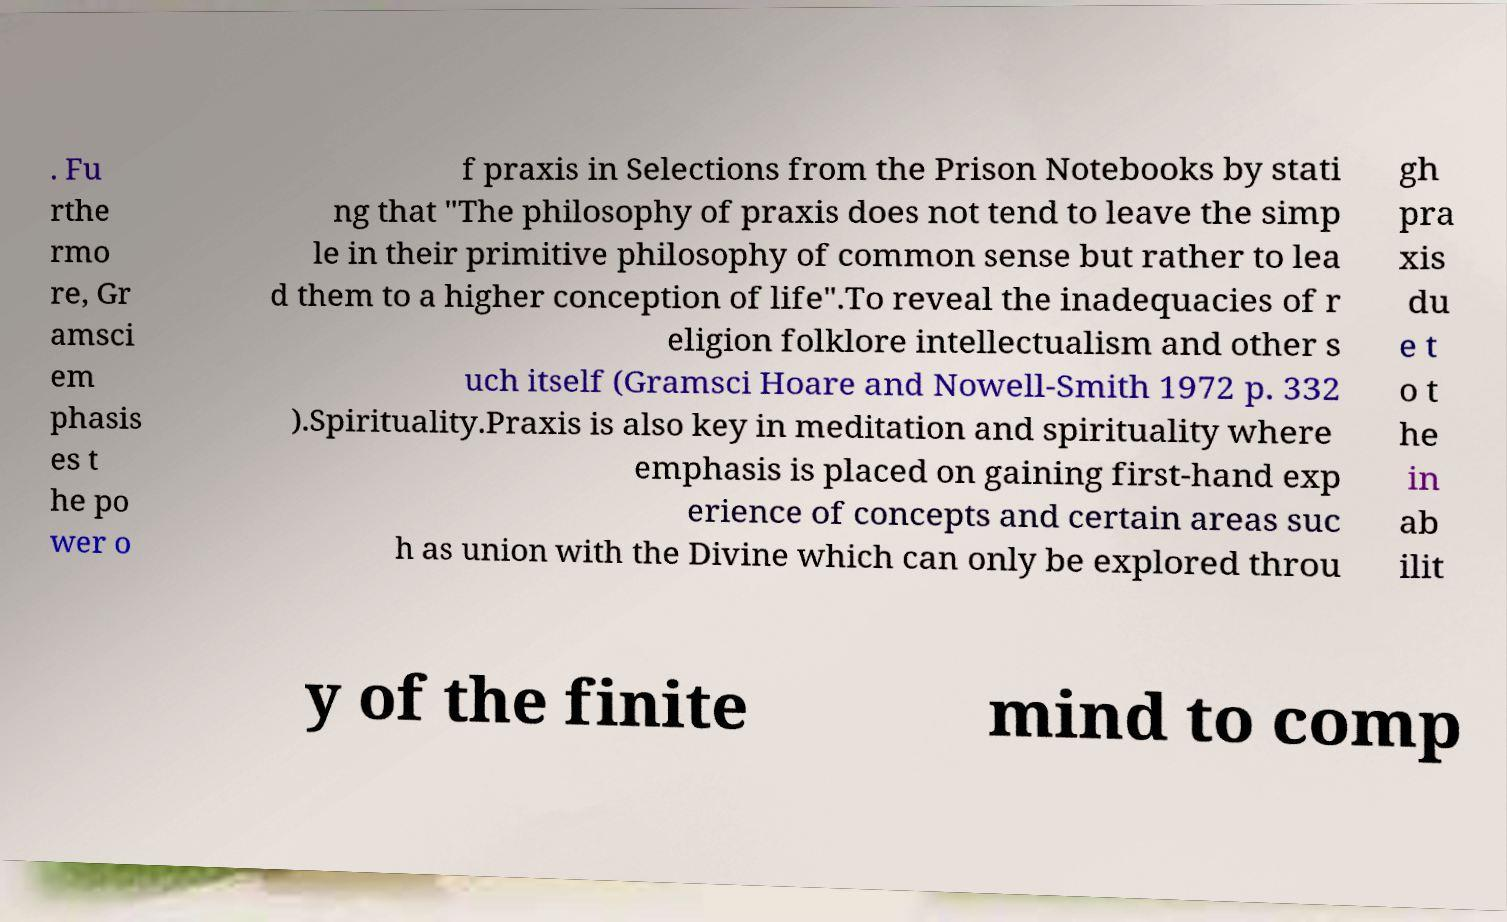I need the written content from this picture converted into text. Can you do that? . Fu rthe rmo re, Gr amsci em phasis es t he po wer o f praxis in Selections from the Prison Notebooks by stati ng that "The philosophy of praxis does not tend to leave the simp le in their primitive philosophy of common sense but rather to lea d them to a higher conception of life".To reveal the inadequacies of r eligion folklore intellectualism and other s uch itself (Gramsci Hoare and Nowell-Smith 1972 p. 332 ).Spirituality.Praxis is also key in meditation and spirituality where emphasis is placed on gaining first-hand exp erience of concepts and certain areas suc h as union with the Divine which can only be explored throu gh pra xis du e t o t he in ab ilit y of the finite mind to comp 